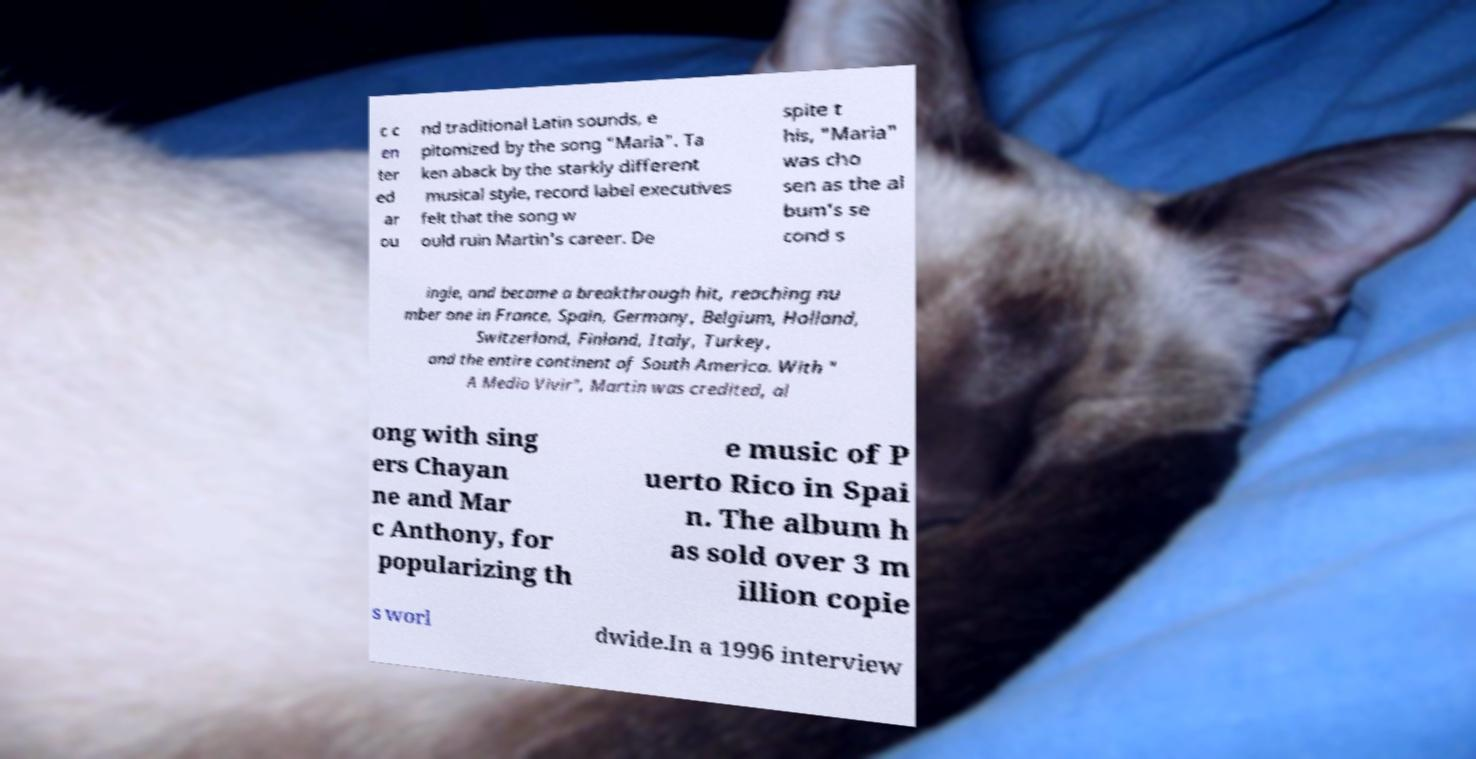Can you accurately transcribe the text from the provided image for me? c c en ter ed ar ou nd traditional Latin sounds, e pitomized by the song "Maria". Ta ken aback by the starkly different musical style, record label executives felt that the song w ould ruin Martin's career. De spite t his, "Maria" was cho sen as the al bum's se cond s ingle, and became a breakthrough hit, reaching nu mber one in France, Spain, Germany, Belgium, Holland, Switzerland, Finland, Italy, Turkey, and the entire continent of South America. With " A Medio Vivir", Martin was credited, al ong with sing ers Chayan ne and Mar c Anthony, for popularizing th e music of P uerto Rico in Spai n. The album h as sold over 3 m illion copie s worl dwide.In a 1996 interview 